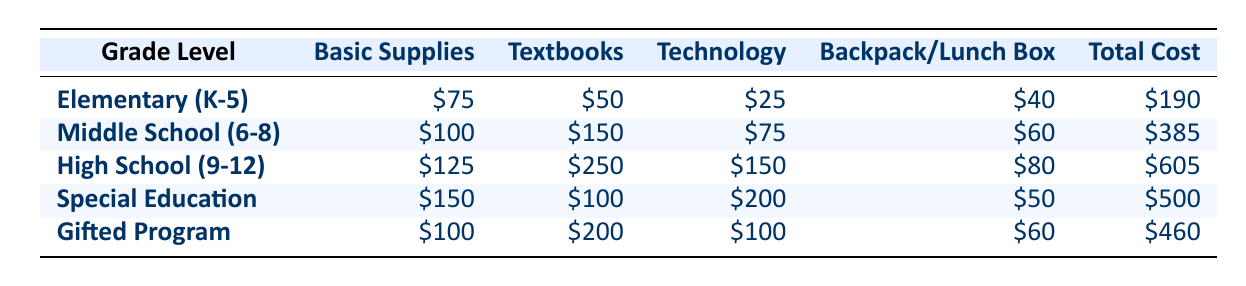What is the total cost of supplies for High School students? The table shows the costs for each grade level, and the total cost for High School (9-12) is listed as $605.
Answer: $605 Which grade level has the highest cost for technology supplies? By examining the technology costs in the table, High School has the highest cost at $150 compared to other grade levels.
Answer: High School (9-12) What is the difference in total cost between Middle School and Elementary (K-5)? The total cost for Middle School is $385 and for Elementary (K-5) it is $190. Subtracting $190 from $385 gives a difference of $195.
Answer: $195 Is the total cost for Special Education greater than the total cost for Gifted Program? The total cost for Special Education is $500 and for Gifted Program it is $460. Since $500 is greater than $460, the statement is true.
Answer: Yes What is the average total cost for the grade levels listed (Elementary, Middle School, High School, Special Education, Gifted Program)? To find the average, we first sum the total costs: $190 + $385 + $605 + $500 + $460 = $2140. There are 5 grade levels, so the average is $2140 divided by 5, which equals $428.
Answer: $428 How much do Elementary (K-5) students spend on backpacks and lunch boxes compared to Special Education students? Elementary (K-5) students spend $40 on backpacks/lunch boxes, while Special Education students spend $50. Subtracting $40 from $50 shows that Special Education students spend $10 more.
Answer: Special Education students spend $10 more Which grade level has the lowest total supply cost? Looking at the total costs in the table, Elementary (K-5) has the lowest total cost of $190 compared to other grade levels.
Answer: Elementary (K-5) Are the total supply costs for the Gifted Program less than the sum of the costs for Basic Supplies and Technology in the Special Education category? For the Gifted Program, the total cost is $460, while the Basic Supplies ($150) and Technology ($200) costs in the Special Education category sum to $350. Since $460 is greater than $350, the statement is false.
Answer: No 